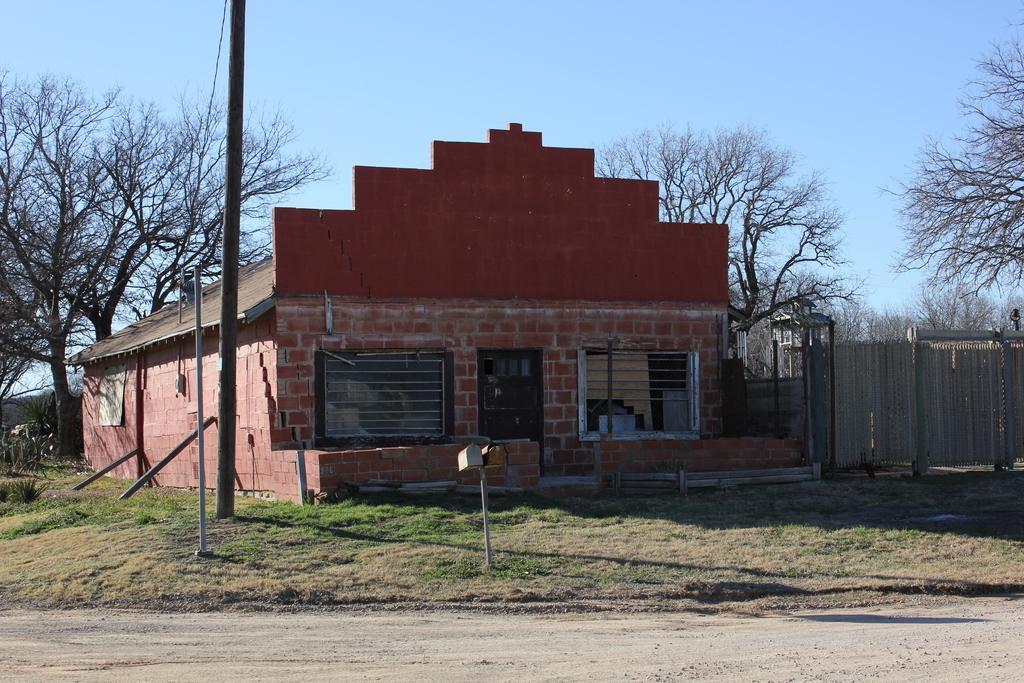In one or two sentences, can you explain what this image depicts? In this image we can see a house, poles, trees, grass and also the fence. We can also see the path at the bottom. Sky is also visible. 